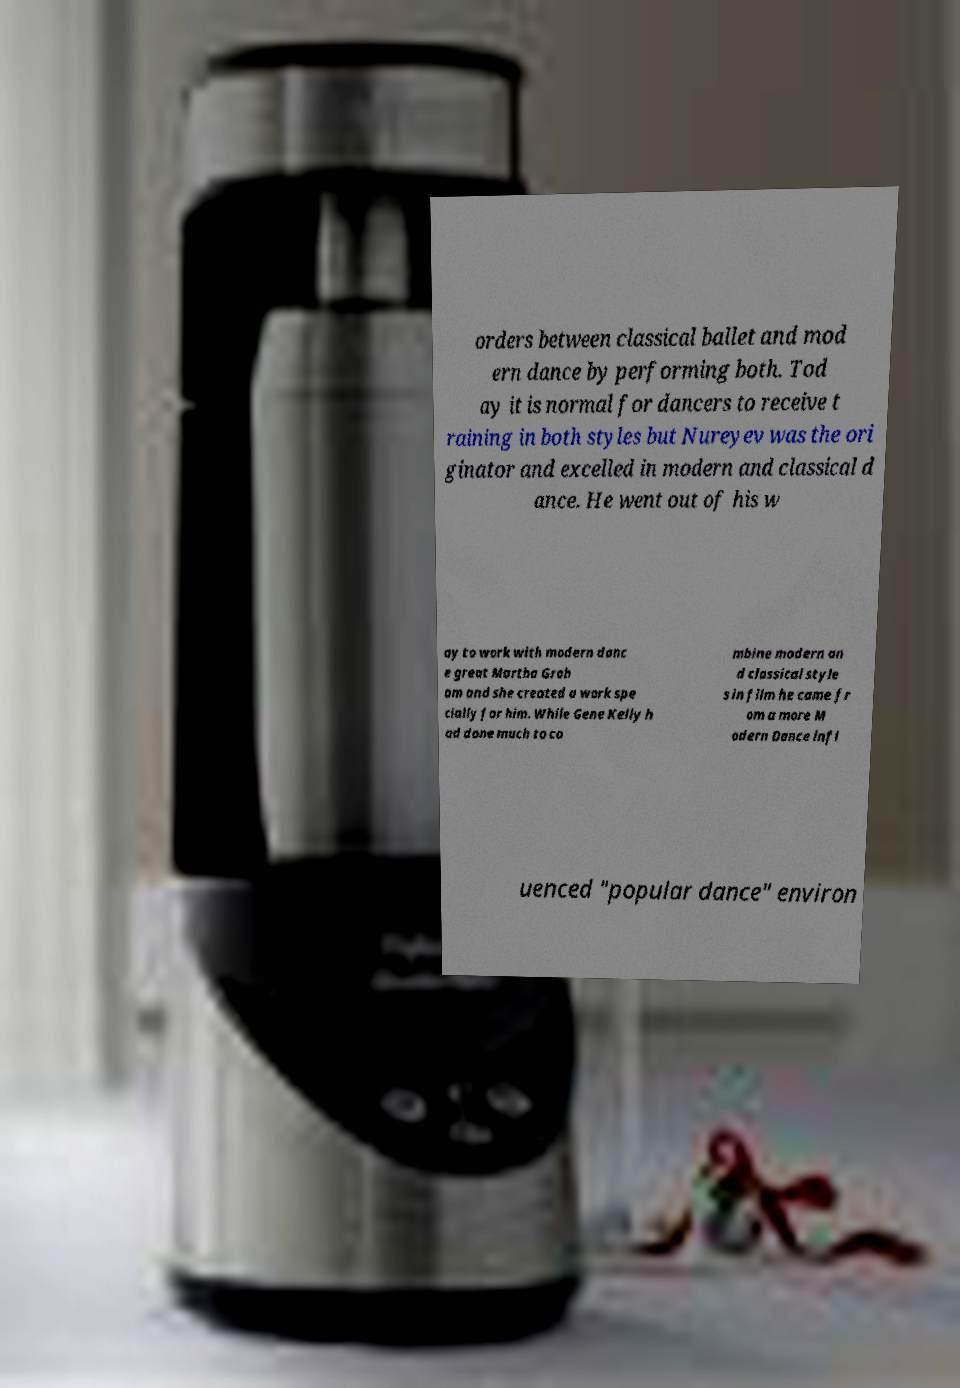Could you extract and type out the text from this image? orders between classical ballet and mod ern dance by performing both. Tod ay it is normal for dancers to receive t raining in both styles but Nureyev was the ori ginator and excelled in modern and classical d ance. He went out of his w ay to work with modern danc e great Martha Grah am and she created a work spe cially for him. While Gene Kelly h ad done much to co mbine modern an d classical style s in film he came fr om a more M odern Dance infl uenced "popular dance" environ 